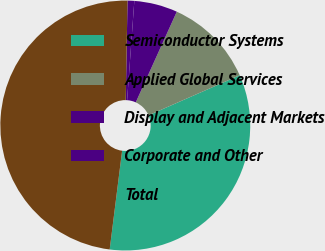Convert chart. <chart><loc_0><loc_0><loc_500><loc_500><pie_chart><fcel>Semiconductor Systems<fcel>Applied Global Services<fcel>Display and Adjacent Markets<fcel>Corporate and Other<fcel>Total<nl><fcel>33.58%<fcel>11.65%<fcel>5.61%<fcel>0.87%<fcel>48.29%<nl></chart> 